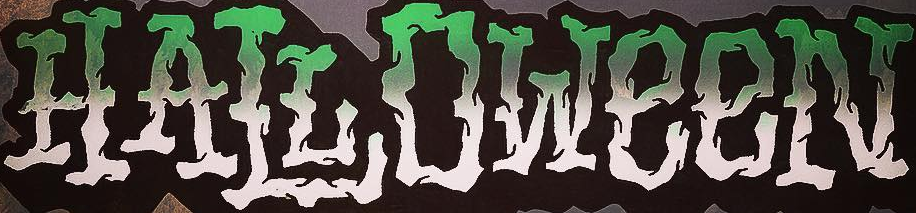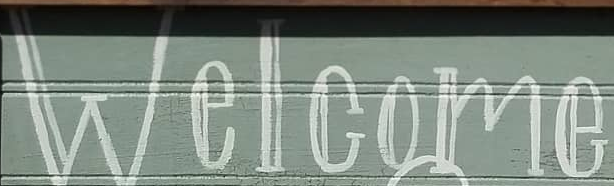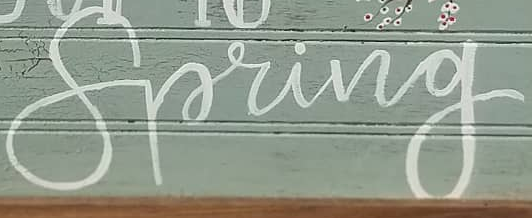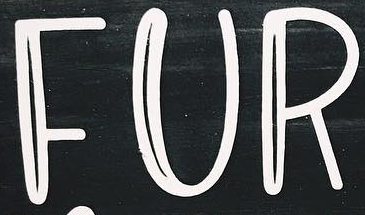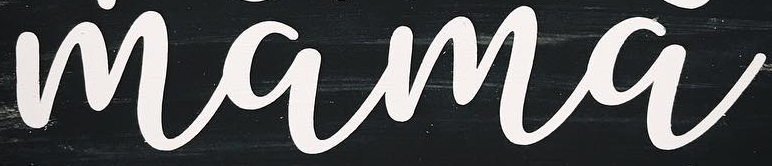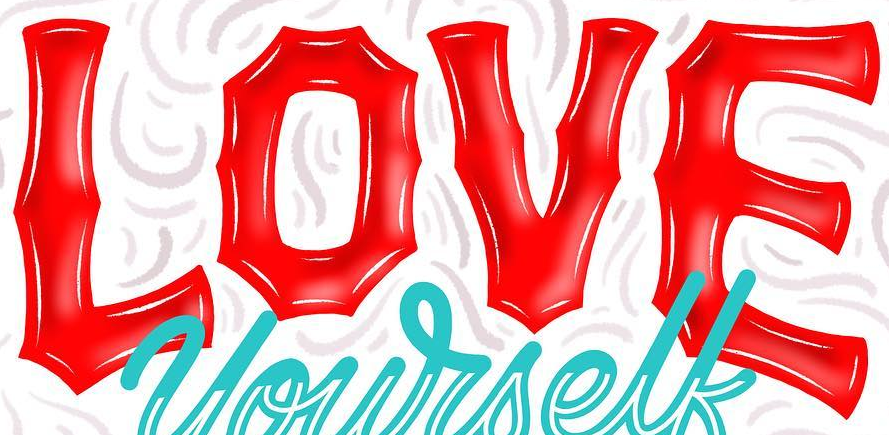Read the text from these images in sequence, separated by a semicolon. HALLOWeeN; Welcome; Spring; FUR; mama; LOVE 